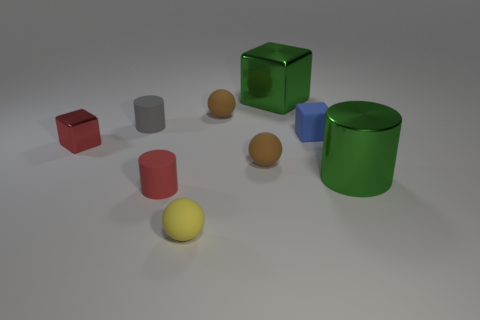Subtract all brown matte balls. How many balls are left? 1 Subtract all red blocks. How many brown spheres are left? 2 Add 1 red matte objects. How many objects exist? 10 Subtract all red cylinders. How many cylinders are left? 2 Subtract all balls. How many objects are left? 6 Subtract 3 cylinders. How many cylinders are left? 0 Subtract all gray rubber cylinders. Subtract all red matte cylinders. How many objects are left? 7 Add 6 large metallic things. How many large metallic things are left? 8 Add 8 tiny cylinders. How many tiny cylinders exist? 10 Subtract 1 red cubes. How many objects are left? 8 